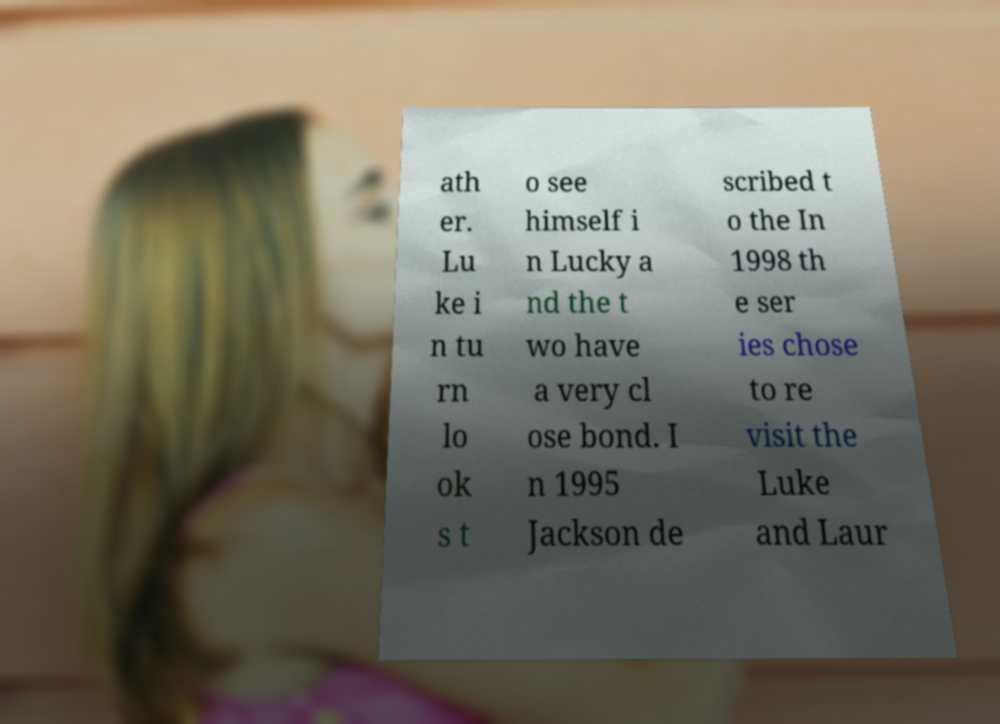Could you extract and type out the text from this image? ath er. Lu ke i n tu rn lo ok s t o see himself i n Lucky a nd the t wo have a very cl ose bond. I n 1995 Jackson de scribed t o the In 1998 th e ser ies chose to re visit the Luke and Laur 